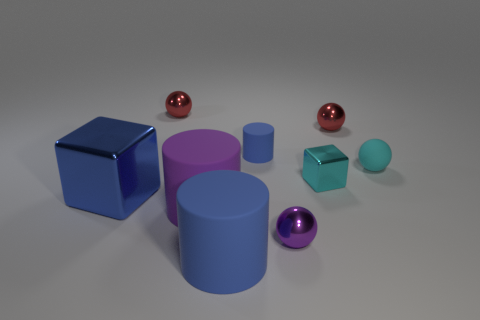Subtract all cyan balls. How many balls are left? 3 Subtract all gray spheres. Subtract all purple cylinders. How many spheres are left? 4 Add 1 tiny red things. How many objects exist? 10 Subtract all blocks. How many objects are left? 7 Subtract 0 yellow cubes. How many objects are left? 9 Subtract all tiny red rubber cubes. Subtract all cyan shiny cubes. How many objects are left? 8 Add 2 cyan metallic objects. How many cyan metallic objects are left? 3 Add 2 green balls. How many green balls exist? 2 